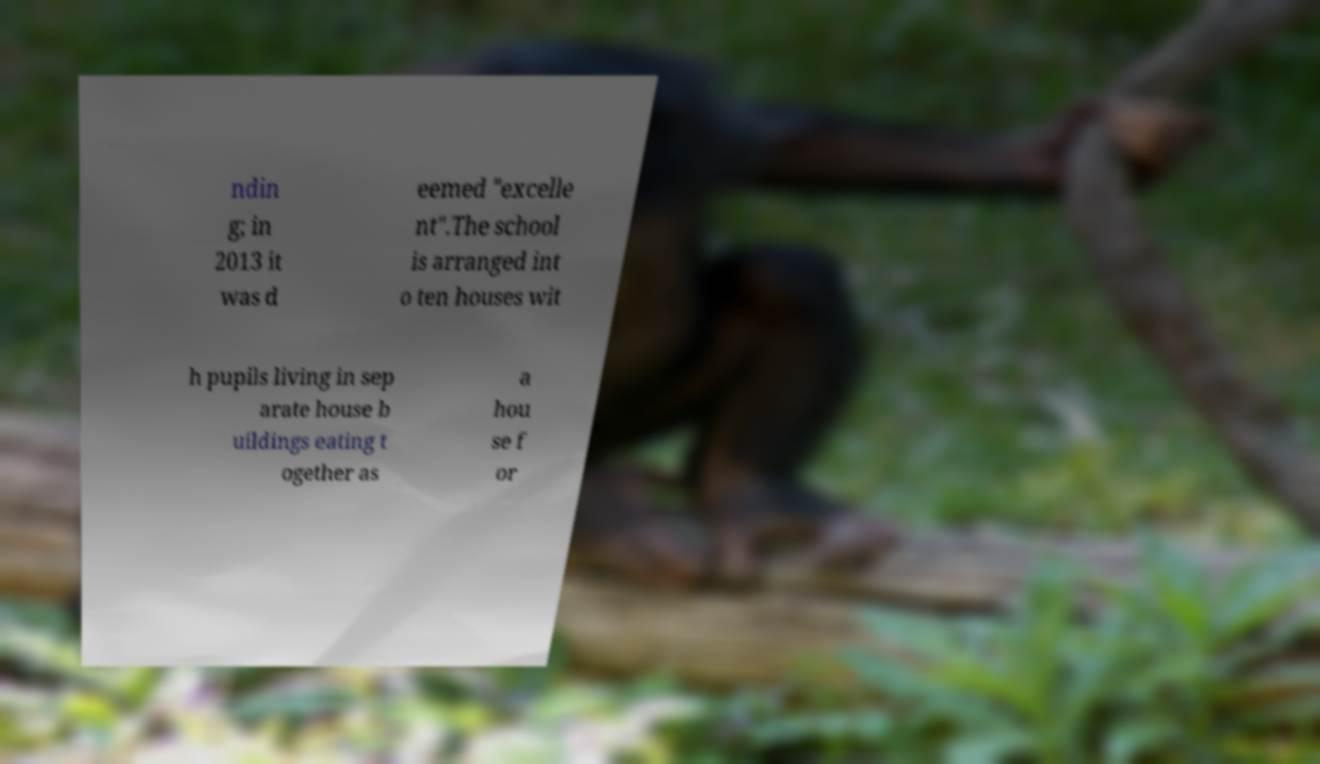Can you accurately transcribe the text from the provided image for me? ndin g; in 2013 it was d eemed "excelle nt".The school is arranged int o ten houses wit h pupils living in sep arate house b uildings eating t ogether as a hou se f or 